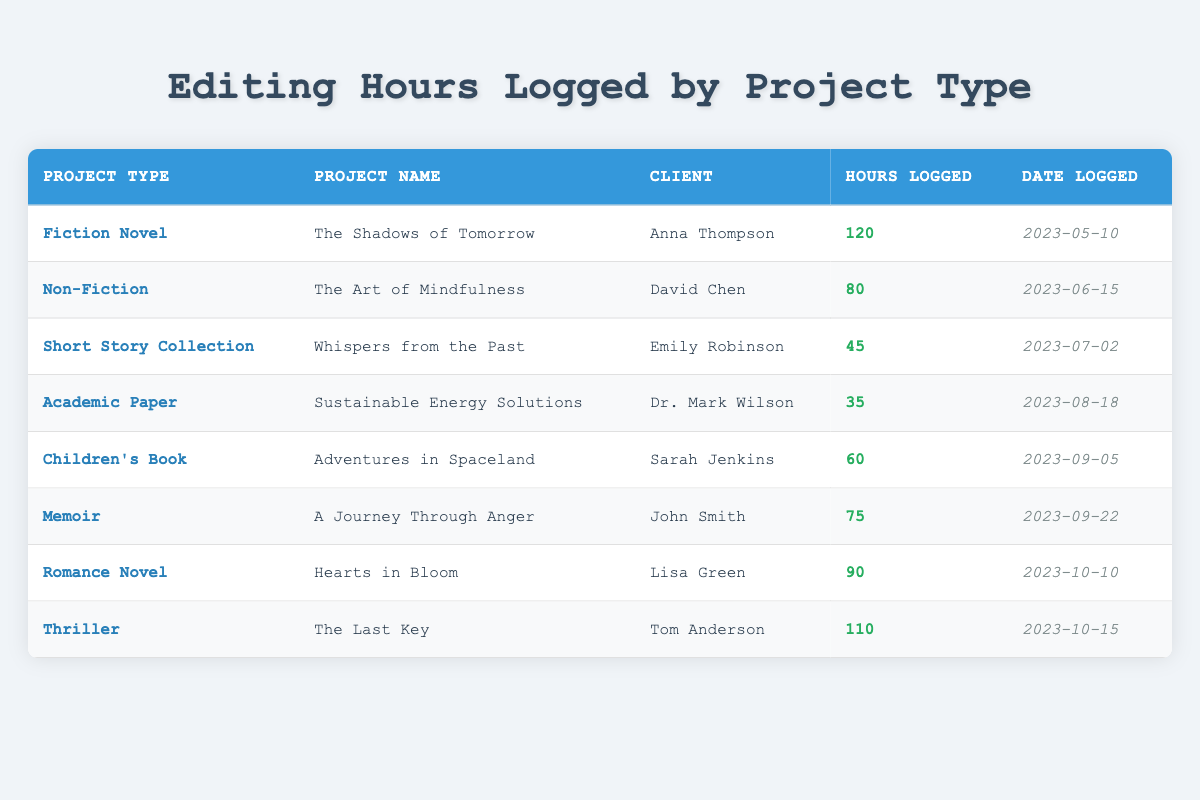What project type logged the most hours? By reviewing the table, we can see that the project type "Fiction Novel" logged 120 hours, which is the highest compared to other project types.
Answer: Fiction Novel How many hours were logged for the Romance Novel? The table indicates that the project "Hearts in Bloom," which is a Romance Novel, had 90 hours logged.
Answer: 90 What is the total number of hours logged for Non-Fiction and Academic Paper combined? Non-Fiction logged 80 hours ("The Art of Mindfulness") and Academic Paper logged 35 hours ("Sustainable Energy Solutions"). Adding these gives 80 + 35 = 115.
Answer: 115 Did any project type have more than 100 hours logged? The table shows that "Fiction Novel" (120 hours) and "Thriller" (110 hours) both exceeded 100 hours. Therefore, the answer is yes.
Answer: Yes What is the average number of hours logged across all projects? To find the average, we sum the hours: 120 + 80 + 45 + 35 + 60 + 75 + 90 + 110 = 510. There are 8 projects total, so we divide 510 by 8, which gives 510 / 8 = 63.75.
Answer: 63.75 Which client had the least hours logged for their project? Reviewing the table, we see that "Sustainable Energy Solutions" for Dr. Mark Wilson logged only 35 hours, which is the least among all projects.
Answer: Dr. Mark Wilson What project type logged the least number of hours? Looking through the table, "Academic Paper" logged 35 hours, which is the lowest count in the table.
Answer: Academic Paper Is the number of hours logged for the Children's Book greater than the average hours logged? The Children's Book "Adventures in Spaceland" logged 60 hours, which is less than the calculated average of 63.75 hours. Therefore, the answer is no.
Answer: No 